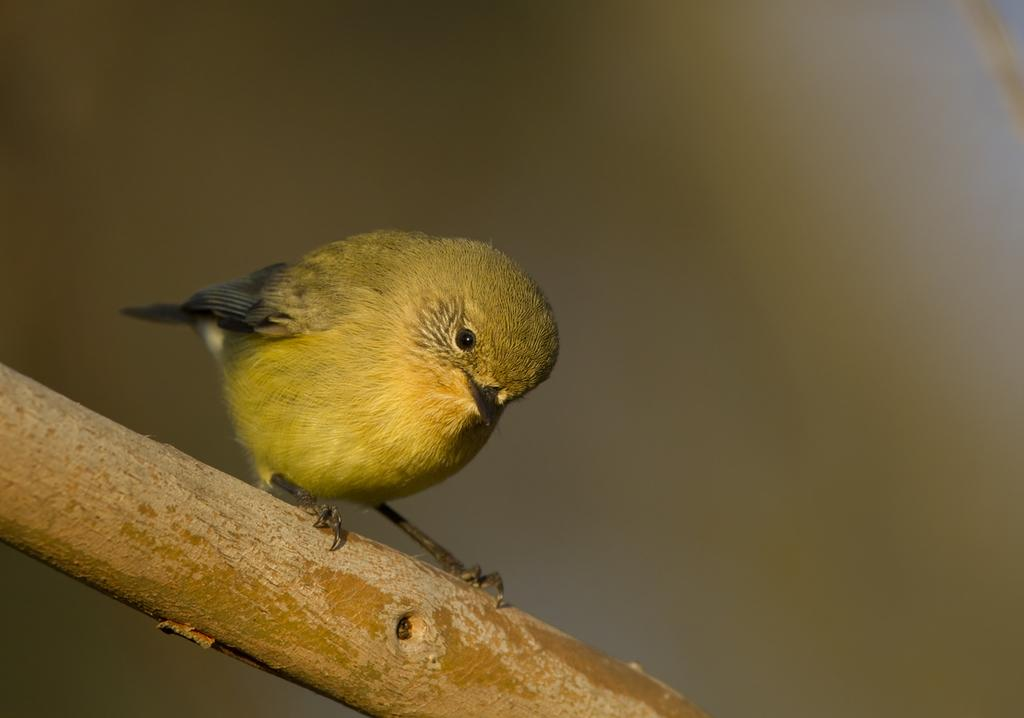What type of animal is in the image? There is a bird in the image. Can you describe the bird's appearance? The bird has green and black coloring. Where is the bird located in the image? The bird is on a branch of a tree. Reasoning: Let' Let's think step by step in order to produce the conversation. We start by identifying the main subject in the image, which is the bird. Then, we expand the conversation to include details about the bird's appearance and location, which are provided in the facts. Each question is designed to elicit a specific detail about the image that is known from the provided facts. Absurd Question/Answer: What letter is the bird holding in its beak in the image? There is no letter present in the image; the bird is on a branch of a tree. What type of bread is the bird eating in the image? There is no bread present in the image; the bird is on a branch of a tree. 